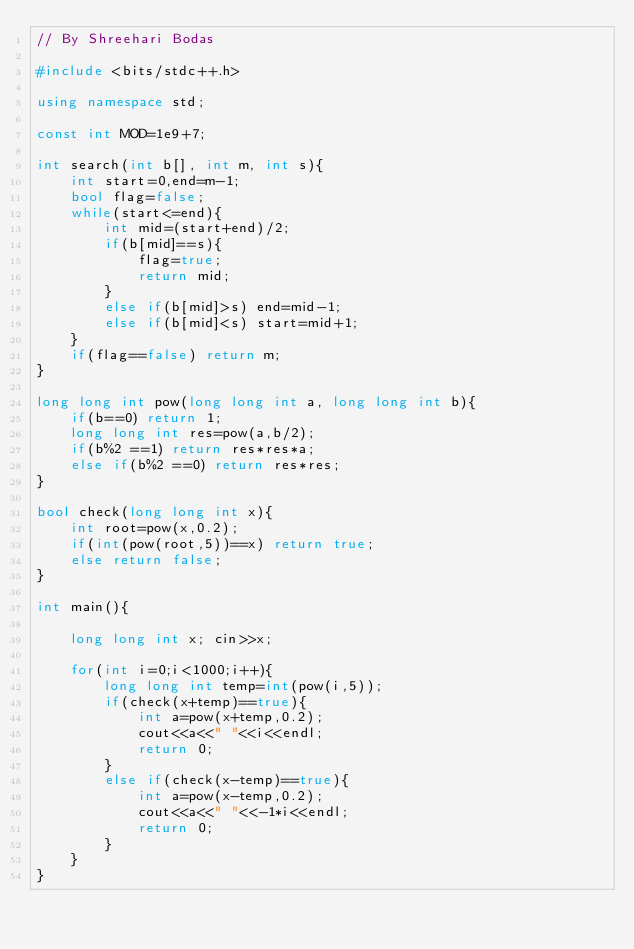<code> <loc_0><loc_0><loc_500><loc_500><_C++_>// By Shreehari Bodas

#include <bits/stdc++.h>

using namespace std;

const int MOD=1e9+7;

int search(int b[], int m, int s){
	int start=0,end=m-1;
	bool flag=false;
	while(start<=end){
		int mid=(start+end)/2;
		if(b[mid]==s){
			flag=true;
			return mid;
		}
		else if(b[mid]>s) end=mid-1;
		else if(b[mid]<s) start=mid+1;
	}
	if(flag==false) return m;
}

long long int pow(long long int a, long long int b){
	if(b==0) return 1;
	long long int res=pow(a,b/2);
	if(b%2 ==1) return res*res*a;
	else if(b%2 ==0) return res*res;
}

bool check(long long int x){
	int root=pow(x,0.2);
	if(int(pow(root,5))==x) return true;
	else return false;
}

int main(){

	long long int x; cin>>x;

	for(int i=0;i<1000;i++){
		long long int temp=int(pow(i,5));
		if(check(x+temp)==true){
			int a=pow(x+temp,0.2);
			cout<<a<<" "<<i<<endl;
			return 0;
		}
		else if(check(x-temp)==true){
			int a=pow(x-temp,0.2);
			cout<<a<<" "<<-1*i<<endl;
			return 0;
		}
	}
} </code> 